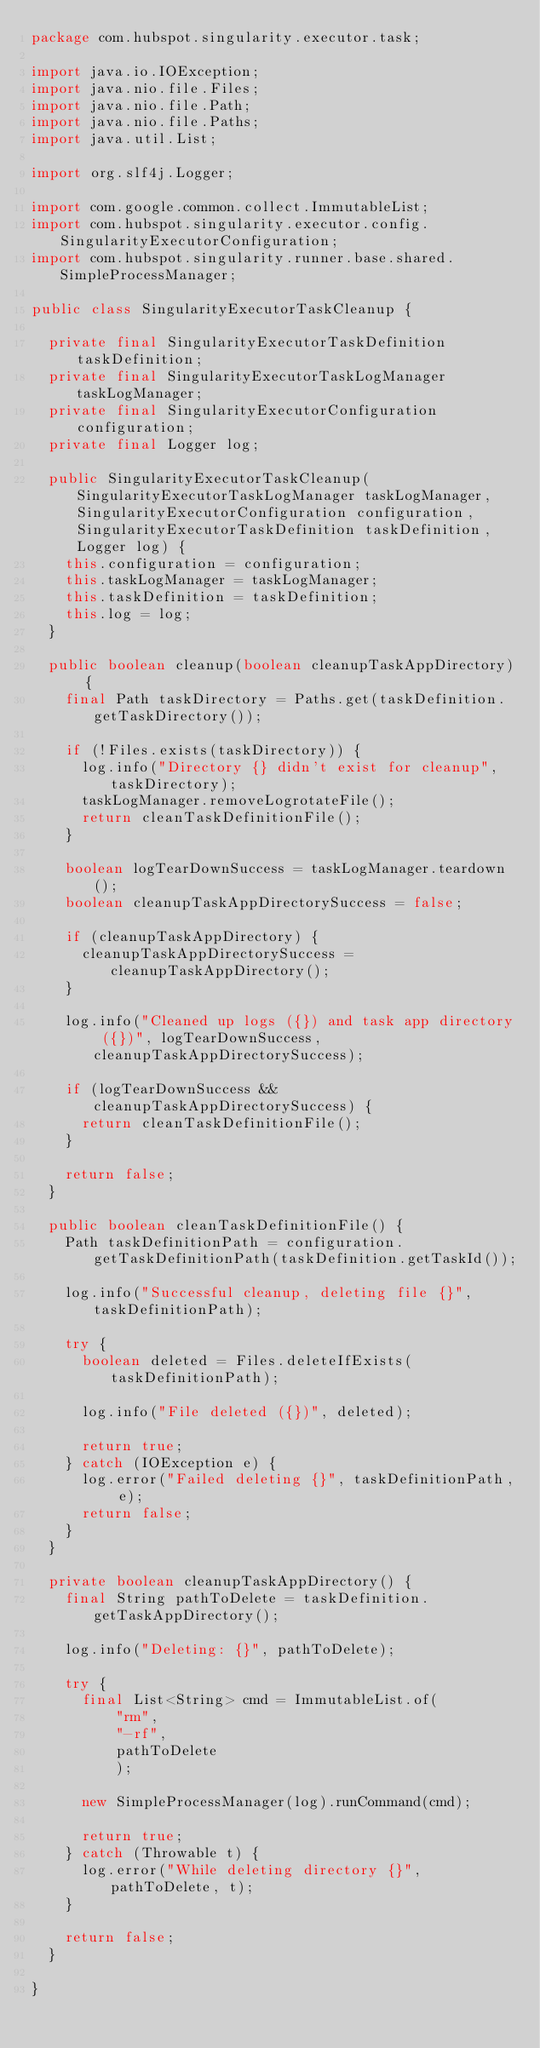<code> <loc_0><loc_0><loc_500><loc_500><_Java_>package com.hubspot.singularity.executor.task;

import java.io.IOException;
import java.nio.file.Files;
import java.nio.file.Path;
import java.nio.file.Paths;
import java.util.List;

import org.slf4j.Logger;

import com.google.common.collect.ImmutableList;
import com.hubspot.singularity.executor.config.SingularityExecutorConfiguration;
import com.hubspot.singularity.runner.base.shared.SimpleProcessManager;

public class SingularityExecutorTaskCleanup {

  private final SingularityExecutorTaskDefinition taskDefinition;
  private final SingularityExecutorTaskLogManager taskLogManager;
  private final SingularityExecutorConfiguration configuration;
  private final Logger log;

  public SingularityExecutorTaskCleanup(SingularityExecutorTaskLogManager taskLogManager, SingularityExecutorConfiguration configuration, SingularityExecutorTaskDefinition taskDefinition, Logger log) {
    this.configuration = configuration;
    this.taskLogManager = taskLogManager;
    this.taskDefinition = taskDefinition;
    this.log = log;
  }

  public boolean cleanup(boolean cleanupTaskAppDirectory) {
    final Path taskDirectory = Paths.get(taskDefinition.getTaskDirectory());

    if (!Files.exists(taskDirectory)) {
      log.info("Directory {} didn't exist for cleanup", taskDirectory);
      taskLogManager.removeLogrotateFile();
      return cleanTaskDefinitionFile();
    }

    boolean logTearDownSuccess = taskLogManager.teardown();
    boolean cleanupTaskAppDirectorySuccess = false;

    if (cleanupTaskAppDirectory) {
      cleanupTaskAppDirectorySuccess = cleanupTaskAppDirectory();
    }

    log.info("Cleaned up logs ({}) and task app directory ({})", logTearDownSuccess, cleanupTaskAppDirectorySuccess);

    if (logTearDownSuccess && cleanupTaskAppDirectorySuccess) {
      return cleanTaskDefinitionFile();
    }

    return false;
  }

  public boolean cleanTaskDefinitionFile() {
    Path taskDefinitionPath = configuration.getTaskDefinitionPath(taskDefinition.getTaskId());

    log.info("Successful cleanup, deleting file {}", taskDefinitionPath);

    try {
      boolean deleted = Files.deleteIfExists(taskDefinitionPath);

      log.info("File deleted ({})", deleted);

      return true;
    } catch (IOException e) {
      log.error("Failed deleting {}", taskDefinitionPath, e);
      return false;
    }
  }

  private boolean cleanupTaskAppDirectory() {
    final String pathToDelete = taskDefinition.getTaskAppDirectory();

    log.info("Deleting: {}", pathToDelete);

    try {
      final List<String> cmd = ImmutableList.of(
          "rm",
          "-rf",
          pathToDelete
          );

      new SimpleProcessManager(log).runCommand(cmd);

      return true;
    } catch (Throwable t) {
      log.error("While deleting directory {}", pathToDelete, t);
    }

    return false;
  }

}
</code> 